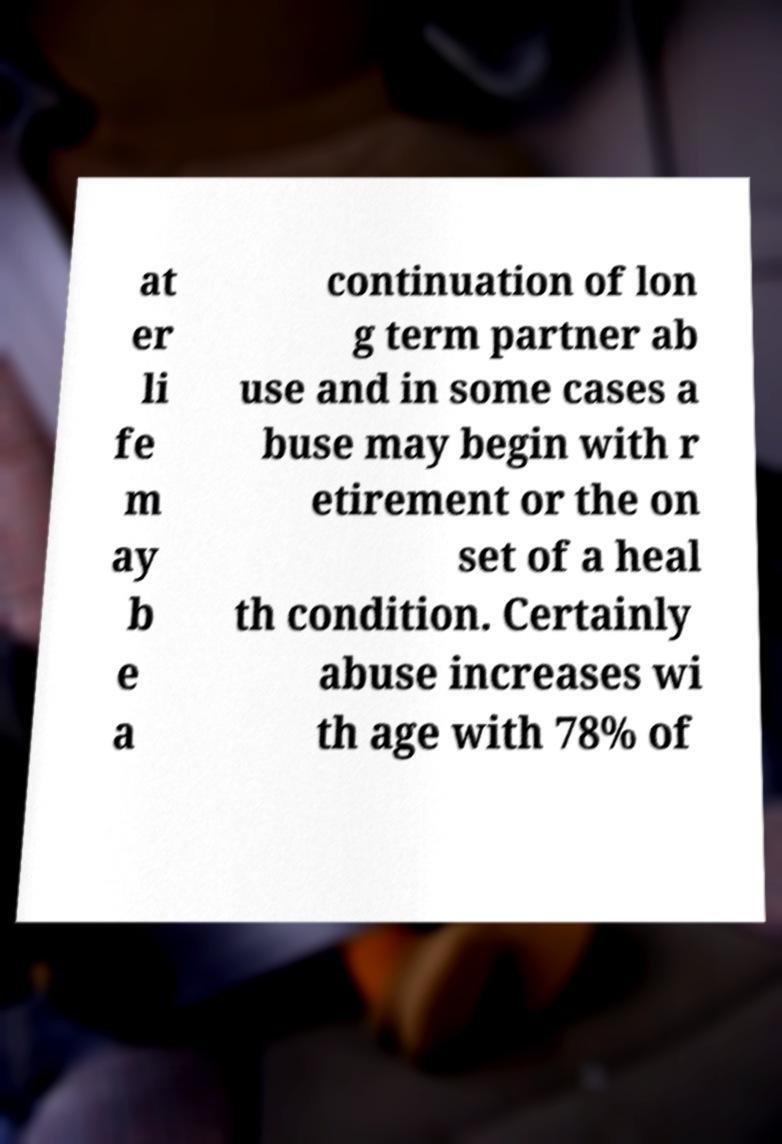Could you assist in decoding the text presented in this image and type it out clearly? at er li fe m ay b e a continuation of lon g term partner ab use and in some cases a buse may begin with r etirement or the on set of a heal th condition. Certainly abuse increases wi th age with 78% of 